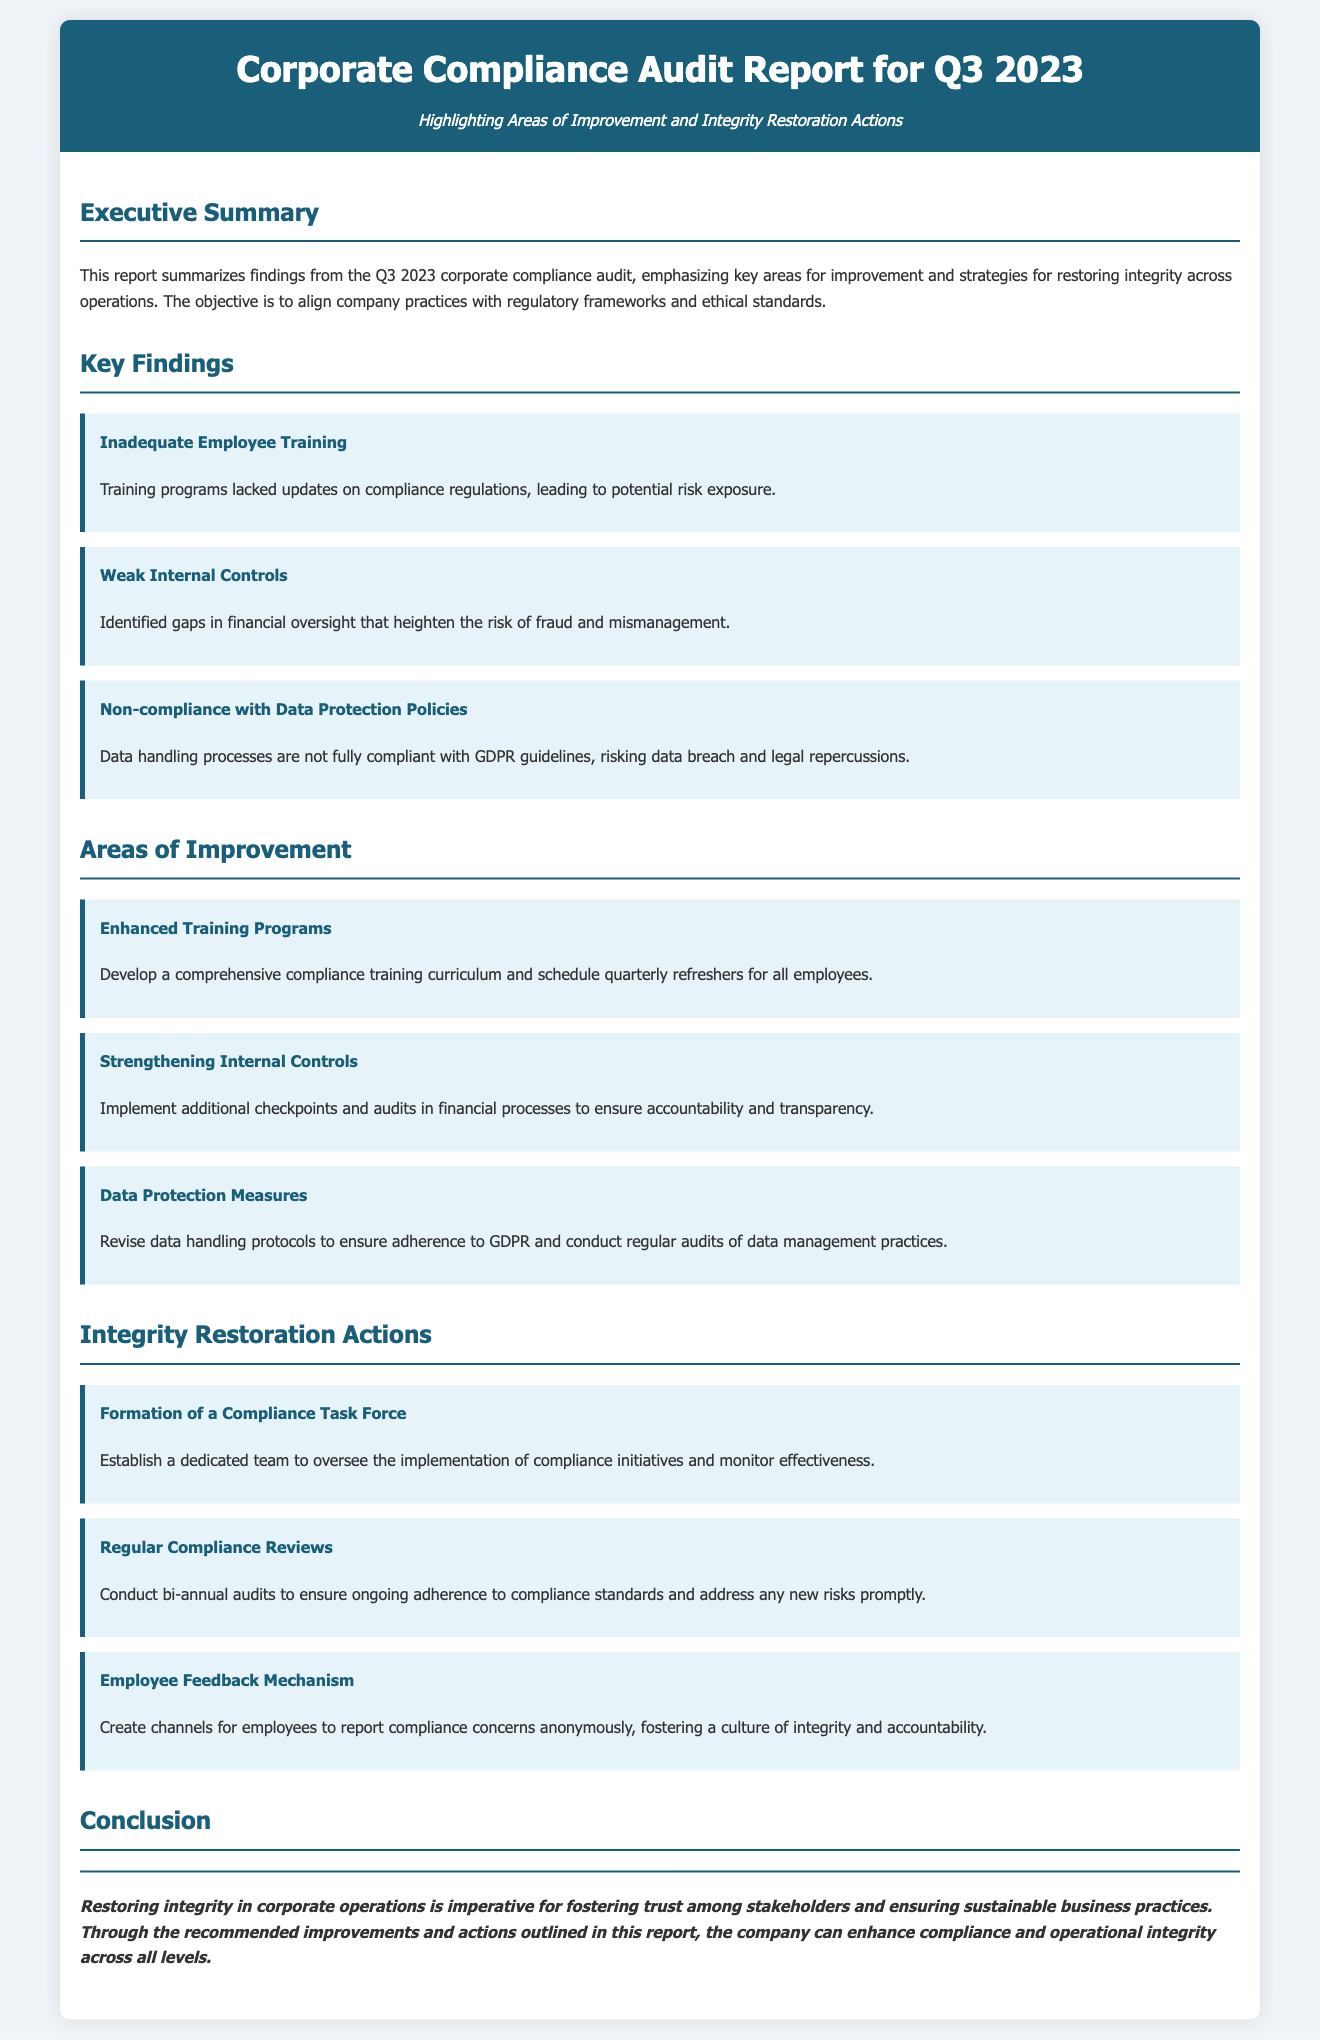What is the title of the report? The document title is prominently displayed at the top.
Answer: Corporate Compliance Audit Report for Q3 2023 What is highlighted in the report? The subtitle indicates the focus of the report.
Answer: Areas of Improvement and Integrity Restoration Actions How many key findings are listed in the document? The various sections provide an overview of key findings.
Answer: Three What is one of the improvement areas mentioned? Specific areas for improvement are detailed within the sections.
Answer: Enhanced Training Programs What compliance measure is recommended? The integrity restoration actions outline specific measures to address issues.
Answer: Formation of a Compliance Task Force What action should be taken regularly according to the report? The integrity restoration section emphasizes the need for consistent evaluations.
Answer: Regular Compliance Reviews What is the conclusion focused on? The final section summarizes the overall intent of the report's recommendations.
Answer: Restoring integrity in corporate operations Which regulatory framework is mentioned in the data protection policies? The report references specific compliance standards relevant to data management.
Answer: GDPR 